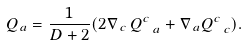Convert formula to latex. <formula><loc_0><loc_0><loc_500><loc_500>Q _ { a } = \frac { 1 } { D + 2 } ( 2 \nabla _ { \, c } \, Q ^ { c } _ { \ a } + \nabla _ { \, a } Q ^ { c } _ { \ c } ) .</formula> 